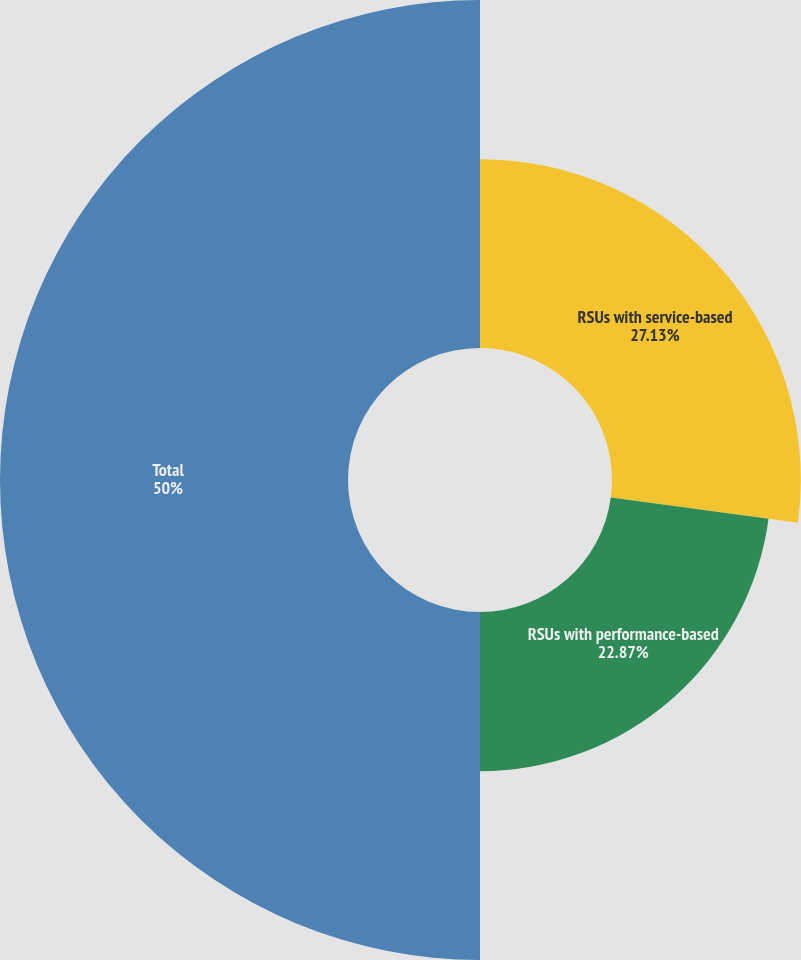<chart> <loc_0><loc_0><loc_500><loc_500><pie_chart><fcel>RSUs with service-based<fcel>RSUs with performance-based<fcel>Total<nl><fcel>27.13%<fcel>22.87%<fcel>50.0%<nl></chart> 